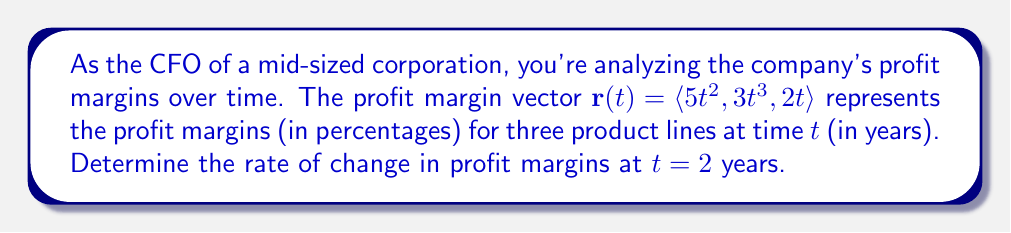Provide a solution to this math problem. To solve this problem, we need to find the derivative of the vector-valued function $\mathbf{r}(t)$ and evaluate it at $t = 2$. This will give us the instantaneous rate of change in profit margins for all three product lines at that time.

1. First, let's find the derivative of $\mathbf{r}(t)$:
   
   $\mathbf{r}(t) = \langle 5t^2, 3t^3, 2t \rangle$
   
   $\mathbf{r}'(t) = \langle \frac{d}{dt}(5t^2), \frac{d}{dt}(3t^3), \frac{d}{dt}(2t) \rangle$
   
   $\mathbf{r}'(t) = \langle 10t, 9t^2, 2 \rangle$

2. Now, we evaluate $\mathbf{r}'(t)$ at $t = 2$:
   
   $\mathbf{r}'(2) = \langle 10(2), 9(2^2), 2 \rangle$
   
   $\mathbf{r}'(2) = \langle 20, 36, 2 \rangle$

3. Interpretation of the result:
   - The first component (20) represents the rate of change in profit margin for the first product line, increasing by 20 percentage points per year.
   - The second component (36) represents the rate of change in profit margin for the second product line, increasing by 36 percentage points per year.
   - The third component (2) represents the rate of change in profit margin for the third product line, increasing by 2 percentage points per year.

This vector gives us a comprehensive view of how quickly profit margins are changing for each product line at t = 2 years.
Answer: The rate of change in profit margins at $t = 2$ years is $\mathbf{r}'(2) = \langle 20, 36, 2 \rangle$ percentage points per year. 